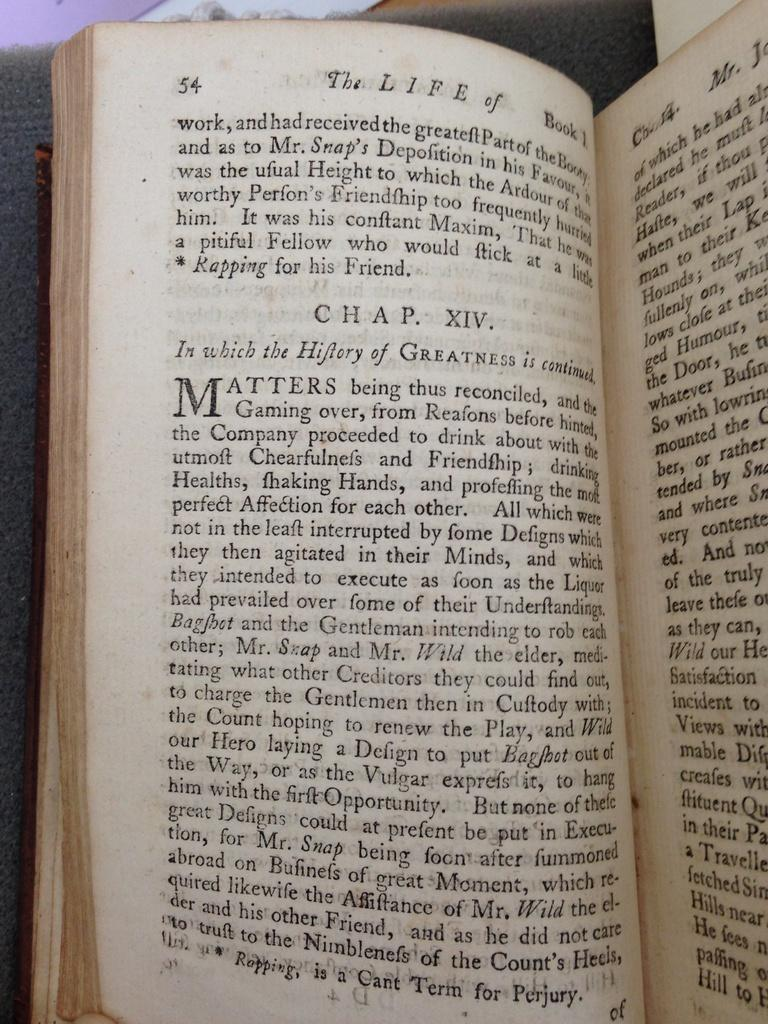<image>
Describe the image concisely. An open book which has the words The  Life of at the top of the page. 